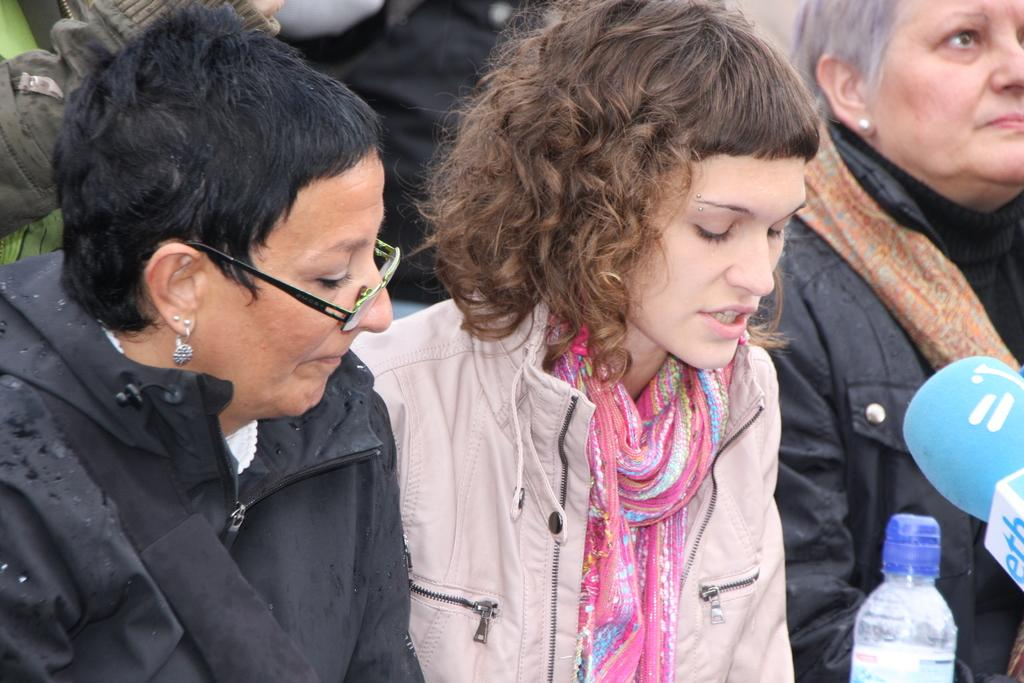How many people are in the image? There are three persons in the image. Can you describe any specific features of one of the persons? One of the persons is wearing spectacles. What objects can be seen in the image besides the people? There is a bottle and a microphone in the image. What type of net is being used to catch the mint in the image? There is no net or mint present in the image. How many muscles can be seen flexing in the image? There are no muscles visible in the image. 